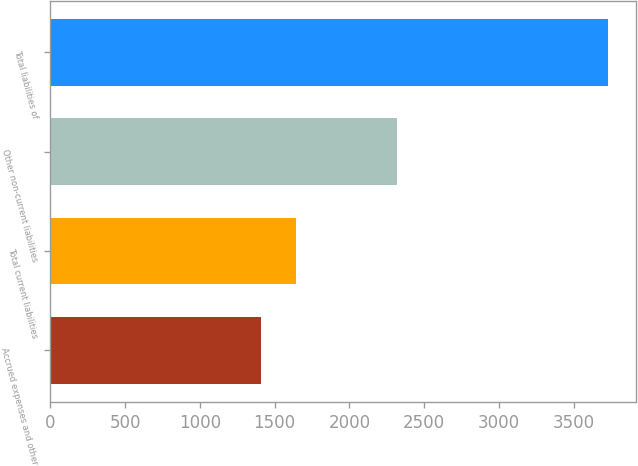<chart> <loc_0><loc_0><loc_500><loc_500><bar_chart><fcel>Accrued expenses and other<fcel>Total current liabilities<fcel>Other non-current liabilities<fcel>Total liabilities of<nl><fcel>1412<fcel>1643.9<fcel>2319<fcel>3731<nl></chart> 